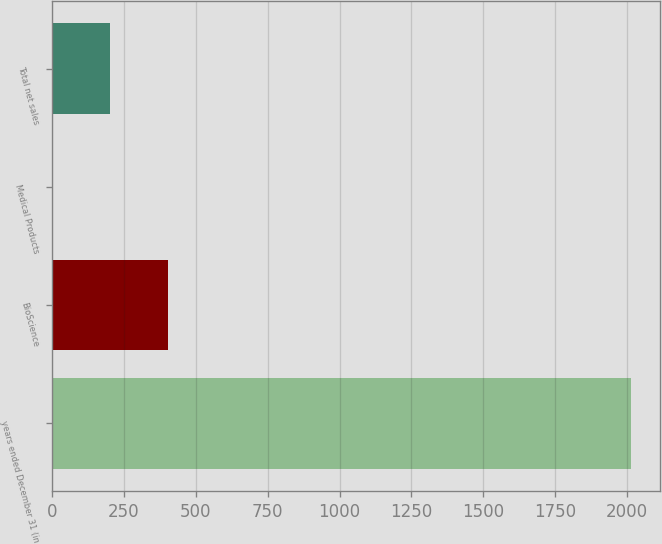Convert chart to OTSL. <chart><loc_0><loc_0><loc_500><loc_500><bar_chart><fcel>years ended December 31 (in<fcel>BioScience<fcel>Medical Products<fcel>Total net sales<nl><fcel>2012<fcel>403.2<fcel>1<fcel>202.1<nl></chart> 